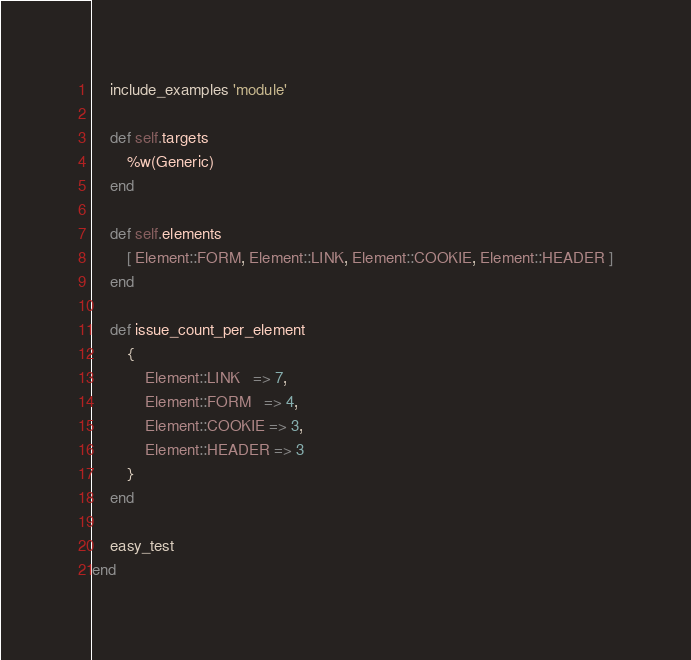<code> <loc_0><loc_0><loc_500><loc_500><_Ruby_>    include_examples 'module'

    def self.targets
        %w(Generic)
    end

    def self.elements
        [ Element::FORM, Element::LINK, Element::COOKIE, Element::HEADER ]
    end

    def issue_count_per_element
        {
            Element::LINK   => 7,
            Element::FORM   => 4,
            Element::COOKIE => 3,
            Element::HEADER => 3
        }
    end

    easy_test
end
</code> 